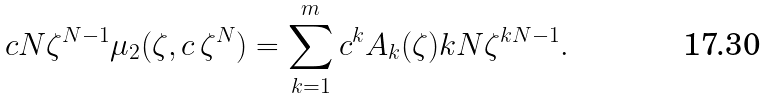Convert formula to latex. <formula><loc_0><loc_0><loc_500><loc_500>c N \zeta ^ { N - 1 } \mu _ { 2 } ( \zeta , c \, \zeta ^ { N } ) = \sum _ { k = 1 } ^ { m } c ^ { k } A _ { k } ( \zeta ) k N \zeta ^ { k N - 1 } .</formula> 